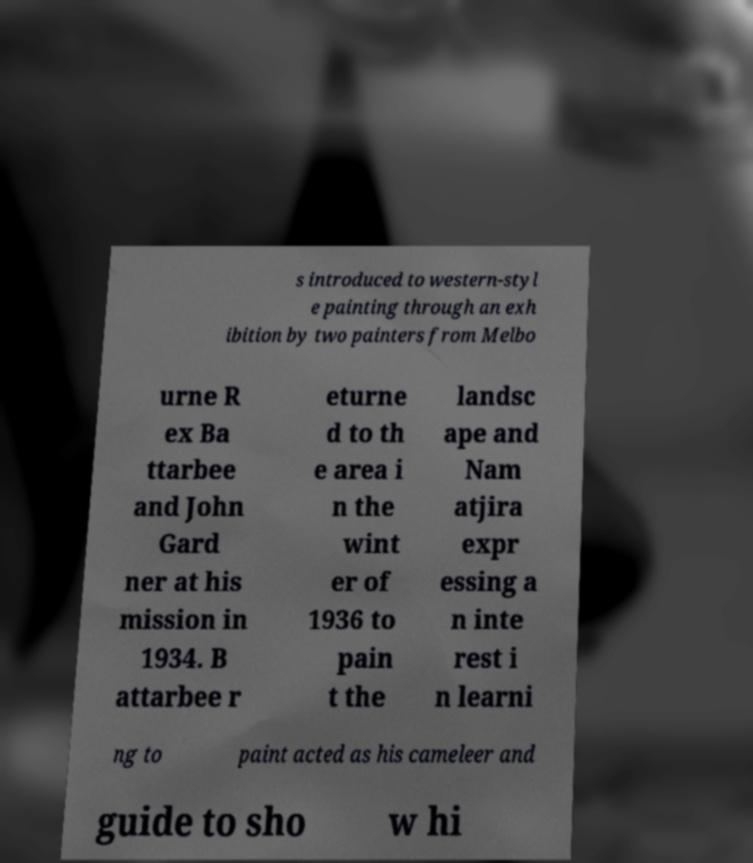Please identify and transcribe the text found in this image. s introduced to western-styl e painting through an exh ibition by two painters from Melbo urne R ex Ba ttarbee and John Gard ner at his mission in 1934. B attarbee r eturne d to th e area i n the wint er of 1936 to pain t the landsc ape and Nam atjira expr essing a n inte rest i n learni ng to paint acted as his cameleer and guide to sho w hi 